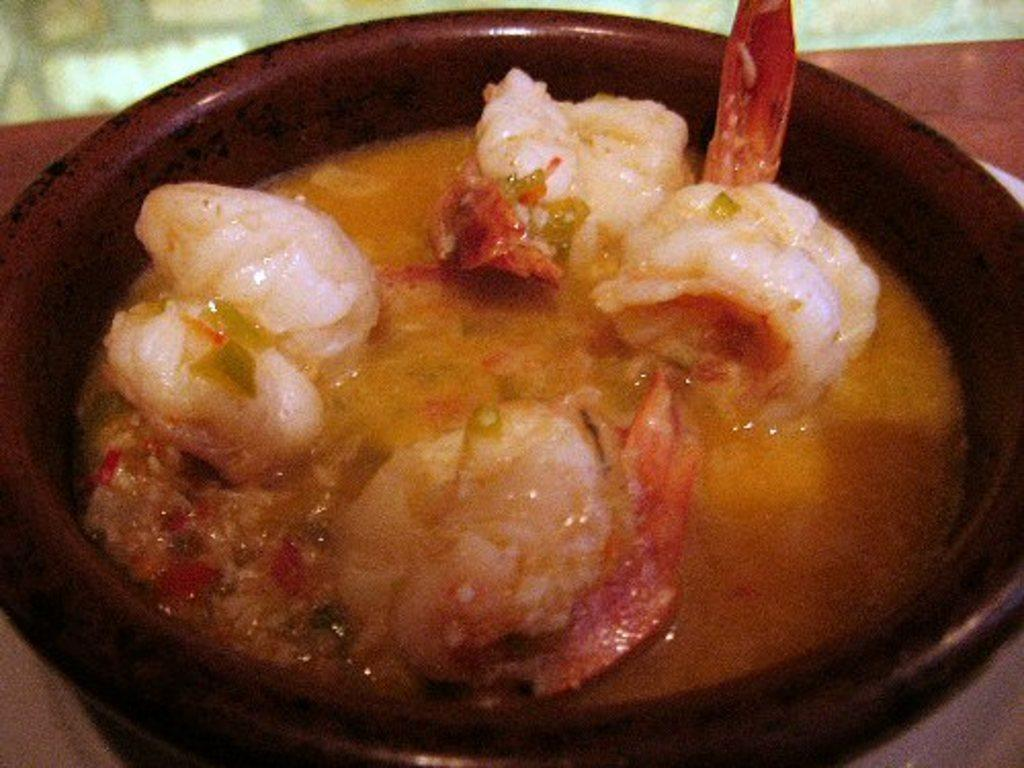What is in the bowl that is visible in the image? There is food in the bowl. Can you describe the colors of the food in the bowl? The food has white, brown, and red colors. What type of bulb is used to light up the cake in the image? There is no cake or bulb present in the image. How many different ways can the food be sorted in the image? The provided facts do not mention any sorting of the food, so it cannot be determined from the image. 